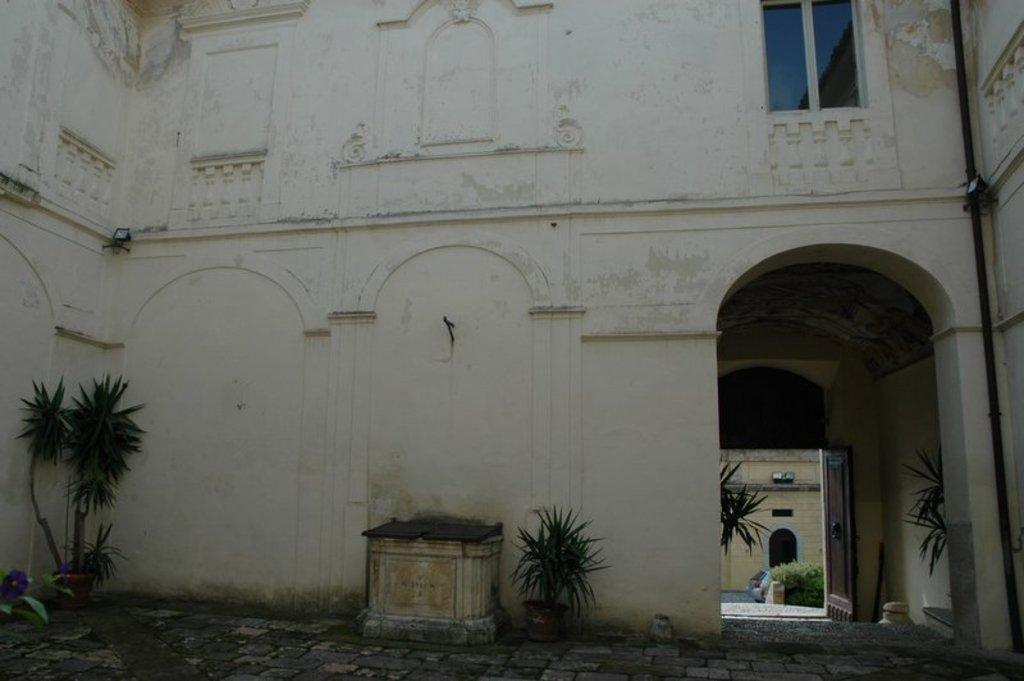What type of structure is present in the image? There is a building in the image. What can be seen illuminating the scene in the image? There are lights in the image. What type of natural elements are present in the image? There are plants in the image. What feature is present for heating or creating a cozy atmosphere? There is a fireplace in the image. What allows for a view of the outside in the image? There is a window in the image. What mode of transportation is visible in the image? There is a vehicle in the image. What surface is visible beneath the other elements in the image? There is a floor visible in the image. Can you tell me how the baby expresses regret in the image? There is no baby present in the image, so it is not possible to determine how a baby might express regret. 